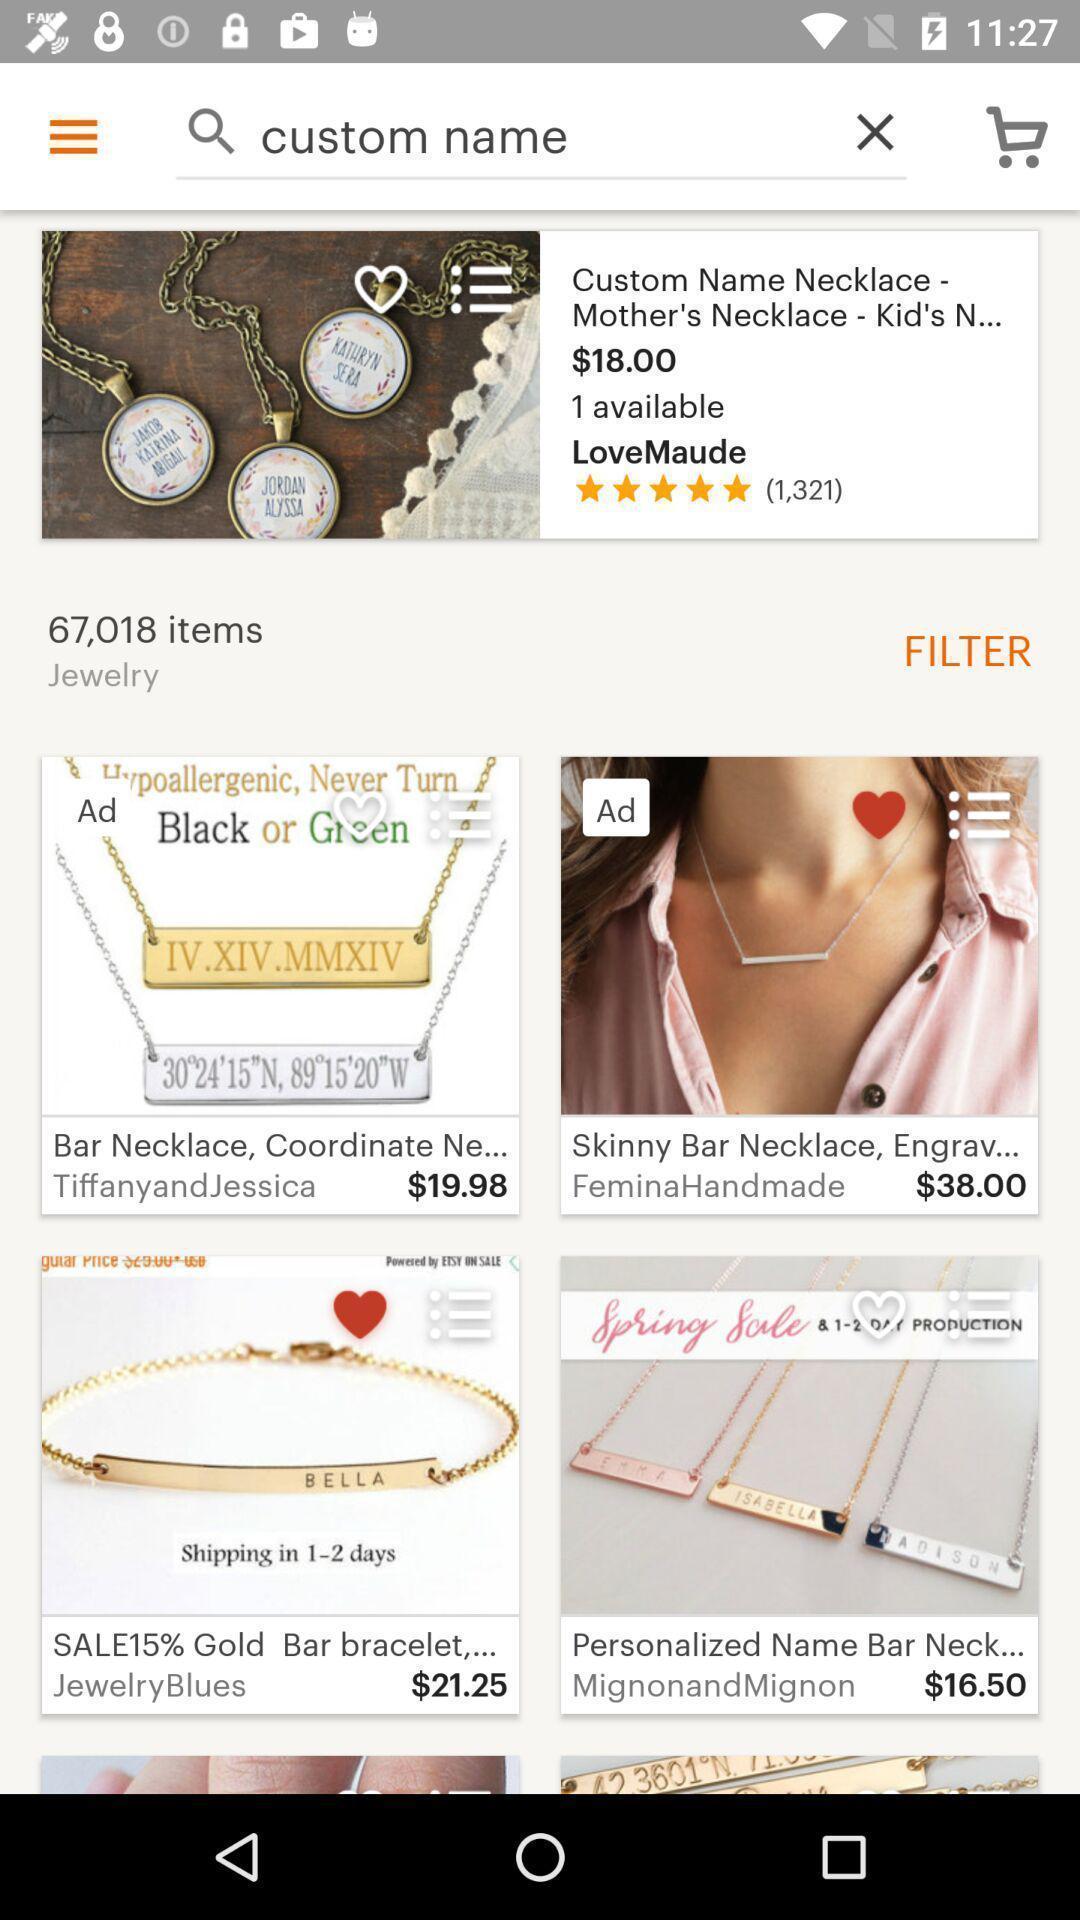What can you discern from this picture? Page showing different products in online shopping. 